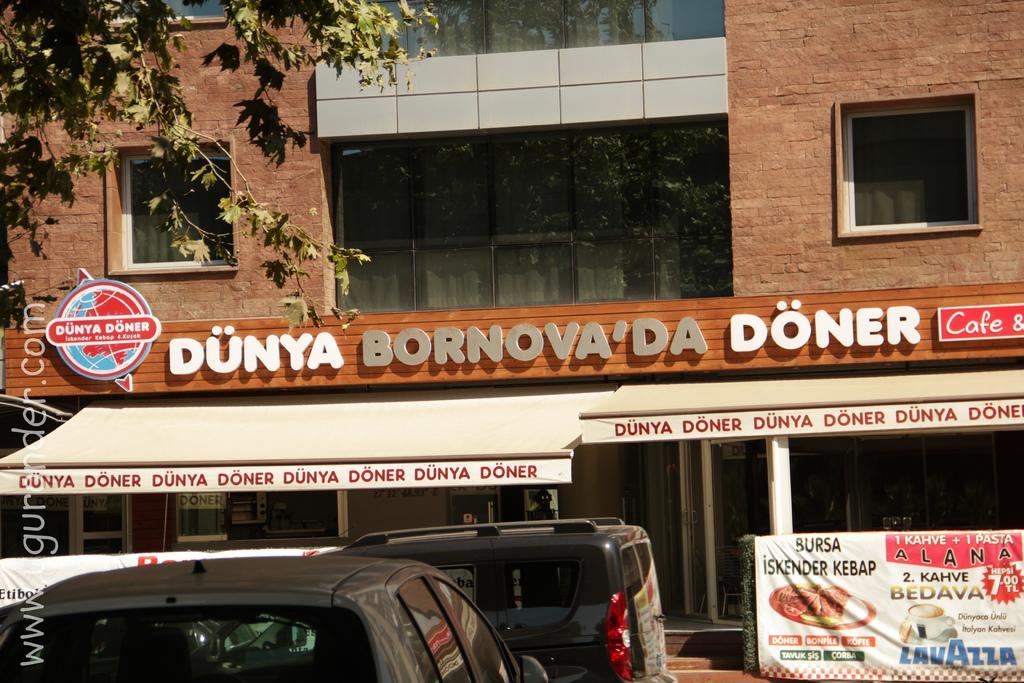Describe this image in one or two sentences. Here at the bottom we can see vehicles and a banner. In the background there is a building,text written on the wall,windows,glass doors and on the left side we can see a tree. 